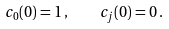<formula> <loc_0><loc_0><loc_500><loc_500>c _ { 0 } ( 0 ) = 1 \, , \quad c _ { j } ( 0 ) = 0 \, .</formula> 